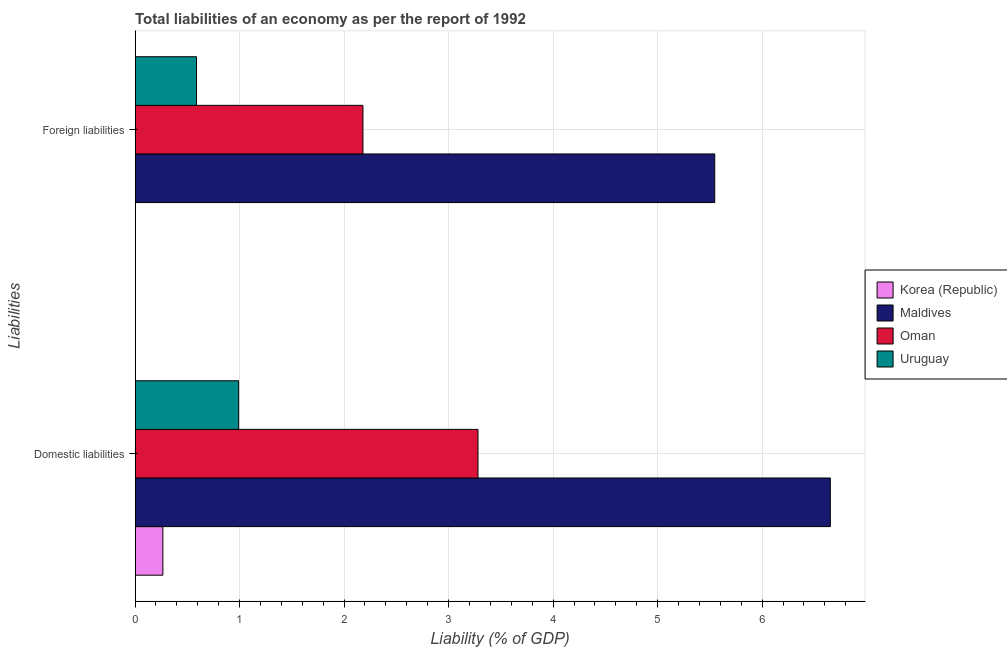How many groups of bars are there?
Give a very brief answer. 2. Are the number of bars on each tick of the Y-axis equal?
Your answer should be compact. No. How many bars are there on the 1st tick from the top?
Provide a short and direct response. 3. What is the label of the 2nd group of bars from the top?
Provide a succinct answer. Domestic liabilities. What is the incurrence of domestic liabilities in Korea (Republic)?
Offer a very short reply. 0.27. Across all countries, what is the maximum incurrence of domestic liabilities?
Make the answer very short. 6.65. Across all countries, what is the minimum incurrence of domestic liabilities?
Keep it short and to the point. 0.27. In which country was the incurrence of domestic liabilities maximum?
Your response must be concise. Maldives. What is the total incurrence of foreign liabilities in the graph?
Offer a very short reply. 8.31. What is the difference between the incurrence of foreign liabilities in Oman and that in Maldives?
Provide a short and direct response. -3.37. What is the difference between the incurrence of domestic liabilities in Oman and the incurrence of foreign liabilities in Korea (Republic)?
Your answer should be very brief. 3.28. What is the average incurrence of domestic liabilities per country?
Your answer should be very brief. 2.8. What is the difference between the incurrence of domestic liabilities and incurrence of foreign liabilities in Uruguay?
Ensure brevity in your answer.  0.4. In how many countries, is the incurrence of foreign liabilities greater than 0.6000000000000001 %?
Your answer should be very brief. 2. What is the ratio of the incurrence of domestic liabilities in Uruguay to that in Oman?
Provide a succinct answer. 0.3. Is the incurrence of domestic liabilities in Korea (Republic) less than that in Maldives?
Your answer should be compact. Yes. Does the graph contain grids?
Make the answer very short. Yes. What is the title of the graph?
Make the answer very short. Total liabilities of an economy as per the report of 1992. What is the label or title of the X-axis?
Offer a very short reply. Liability (% of GDP). What is the label or title of the Y-axis?
Your answer should be very brief. Liabilities. What is the Liability (% of GDP) of Korea (Republic) in Domestic liabilities?
Ensure brevity in your answer.  0.27. What is the Liability (% of GDP) of Maldives in Domestic liabilities?
Your response must be concise. 6.65. What is the Liability (% of GDP) of Oman in Domestic liabilities?
Make the answer very short. 3.28. What is the Liability (% of GDP) of Uruguay in Domestic liabilities?
Make the answer very short. 0.99. What is the Liability (% of GDP) of Maldives in Foreign liabilities?
Give a very brief answer. 5.55. What is the Liability (% of GDP) in Oman in Foreign liabilities?
Ensure brevity in your answer.  2.18. What is the Liability (% of GDP) of Uruguay in Foreign liabilities?
Offer a terse response. 0.59. Across all Liabilities, what is the maximum Liability (% of GDP) in Korea (Republic)?
Your answer should be compact. 0.27. Across all Liabilities, what is the maximum Liability (% of GDP) in Maldives?
Give a very brief answer. 6.65. Across all Liabilities, what is the maximum Liability (% of GDP) of Oman?
Offer a terse response. 3.28. Across all Liabilities, what is the maximum Liability (% of GDP) of Uruguay?
Make the answer very short. 0.99. Across all Liabilities, what is the minimum Liability (% of GDP) in Maldives?
Make the answer very short. 5.55. Across all Liabilities, what is the minimum Liability (% of GDP) in Oman?
Give a very brief answer. 2.18. Across all Liabilities, what is the minimum Liability (% of GDP) in Uruguay?
Your answer should be compact. 0.59. What is the total Liability (% of GDP) in Korea (Republic) in the graph?
Provide a short and direct response. 0.27. What is the total Liability (% of GDP) of Maldives in the graph?
Keep it short and to the point. 12.2. What is the total Liability (% of GDP) in Oman in the graph?
Ensure brevity in your answer.  5.46. What is the total Liability (% of GDP) in Uruguay in the graph?
Offer a very short reply. 1.58. What is the difference between the Liability (% of GDP) in Maldives in Domestic liabilities and that in Foreign liabilities?
Offer a terse response. 1.11. What is the difference between the Liability (% of GDP) of Oman in Domestic liabilities and that in Foreign liabilities?
Give a very brief answer. 1.1. What is the difference between the Liability (% of GDP) of Uruguay in Domestic liabilities and that in Foreign liabilities?
Your answer should be very brief. 0.4. What is the difference between the Liability (% of GDP) of Korea (Republic) in Domestic liabilities and the Liability (% of GDP) of Maldives in Foreign liabilities?
Keep it short and to the point. -5.28. What is the difference between the Liability (% of GDP) in Korea (Republic) in Domestic liabilities and the Liability (% of GDP) in Oman in Foreign liabilities?
Offer a very short reply. -1.91. What is the difference between the Liability (% of GDP) in Korea (Republic) in Domestic liabilities and the Liability (% of GDP) in Uruguay in Foreign liabilities?
Keep it short and to the point. -0.32. What is the difference between the Liability (% of GDP) in Maldives in Domestic liabilities and the Liability (% of GDP) in Oman in Foreign liabilities?
Your response must be concise. 4.47. What is the difference between the Liability (% of GDP) in Maldives in Domestic liabilities and the Liability (% of GDP) in Uruguay in Foreign liabilities?
Keep it short and to the point. 6.06. What is the difference between the Liability (% of GDP) in Oman in Domestic liabilities and the Liability (% of GDP) in Uruguay in Foreign liabilities?
Offer a very short reply. 2.69. What is the average Liability (% of GDP) of Korea (Republic) per Liabilities?
Give a very brief answer. 0.13. What is the average Liability (% of GDP) of Maldives per Liabilities?
Ensure brevity in your answer.  6.1. What is the average Liability (% of GDP) in Oman per Liabilities?
Your response must be concise. 2.73. What is the average Liability (% of GDP) of Uruguay per Liabilities?
Offer a terse response. 0.79. What is the difference between the Liability (% of GDP) of Korea (Republic) and Liability (% of GDP) of Maldives in Domestic liabilities?
Make the answer very short. -6.39. What is the difference between the Liability (% of GDP) in Korea (Republic) and Liability (% of GDP) in Oman in Domestic liabilities?
Provide a short and direct response. -3.02. What is the difference between the Liability (% of GDP) in Korea (Republic) and Liability (% of GDP) in Uruguay in Domestic liabilities?
Give a very brief answer. -0.72. What is the difference between the Liability (% of GDP) of Maldives and Liability (% of GDP) of Oman in Domestic liabilities?
Your response must be concise. 3.37. What is the difference between the Liability (% of GDP) of Maldives and Liability (% of GDP) of Uruguay in Domestic liabilities?
Make the answer very short. 5.66. What is the difference between the Liability (% of GDP) in Oman and Liability (% of GDP) in Uruguay in Domestic liabilities?
Provide a short and direct response. 2.29. What is the difference between the Liability (% of GDP) in Maldives and Liability (% of GDP) in Oman in Foreign liabilities?
Ensure brevity in your answer.  3.37. What is the difference between the Liability (% of GDP) of Maldives and Liability (% of GDP) of Uruguay in Foreign liabilities?
Your answer should be very brief. 4.96. What is the difference between the Liability (% of GDP) in Oman and Liability (% of GDP) in Uruguay in Foreign liabilities?
Make the answer very short. 1.59. What is the ratio of the Liability (% of GDP) in Maldives in Domestic liabilities to that in Foreign liabilities?
Your response must be concise. 1.2. What is the ratio of the Liability (% of GDP) in Oman in Domestic liabilities to that in Foreign liabilities?
Provide a short and direct response. 1.5. What is the ratio of the Liability (% of GDP) in Uruguay in Domestic liabilities to that in Foreign liabilities?
Your answer should be compact. 1.69. What is the difference between the highest and the second highest Liability (% of GDP) in Maldives?
Ensure brevity in your answer.  1.11. What is the difference between the highest and the second highest Liability (% of GDP) of Oman?
Provide a short and direct response. 1.1. What is the difference between the highest and the second highest Liability (% of GDP) in Uruguay?
Your response must be concise. 0.4. What is the difference between the highest and the lowest Liability (% of GDP) in Korea (Republic)?
Provide a succinct answer. 0.27. What is the difference between the highest and the lowest Liability (% of GDP) in Maldives?
Make the answer very short. 1.11. What is the difference between the highest and the lowest Liability (% of GDP) in Oman?
Offer a terse response. 1.1. What is the difference between the highest and the lowest Liability (% of GDP) in Uruguay?
Your response must be concise. 0.4. 